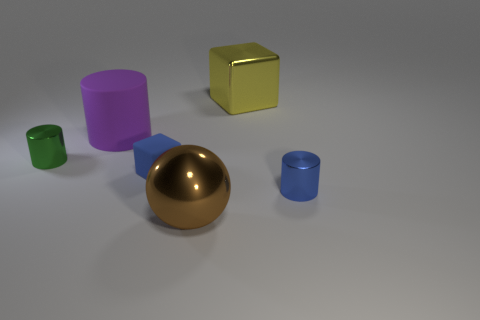Do the tiny blue object on the left side of the big metal sphere and the cube that is on the right side of the sphere have the same material?
Provide a succinct answer. No. Are there any other things that have the same shape as the brown object?
Give a very brief answer. No. Are the tiny block and the cylinder on the right side of the large purple object made of the same material?
Provide a succinct answer. No. The large metal thing in front of the metal cylinder that is on the left side of the tiny metal thing that is right of the small green cylinder is what color?
Keep it short and to the point. Brown. The blue shiny object that is the same size as the blue matte block is what shape?
Offer a terse response. Cylinder. Is the size of the shiny cylinder in front of the small blue matte cube the same as the blue object that is to the left of the sphere?
Your answer should be very brief. Yes. There is a block on the right side of the big brown metallic ball; what is its size?
Give a very brief answer. Large. What is the material of the tiny thing that is the same color as the matte cube?
Make the answer very short. Metal. What is the color of the matte block that is the same size as the blue metal thing?
Your answer should be compact. Blue. Is the size of the brown thing the same as the blue cylinder?
Your response must be concise. No. 